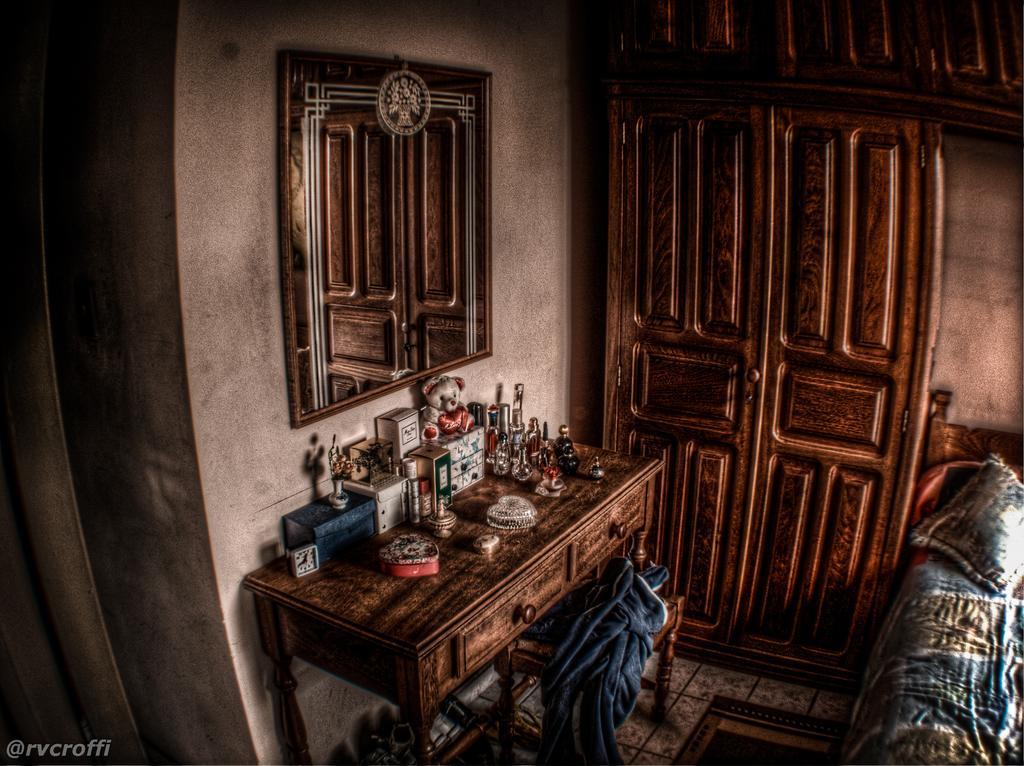In one or two sentences, can you explain what this image depicts? This is a room. On the right side there is a bed with pillow. Near to that there is a wooden cupboard. On the right side there is a curtain. On the wall there is a mirror. Also there is a table. Near to that there is a stool. On that there is a cloth. On the table there are boxes, clock, teddy bear and many other items. 